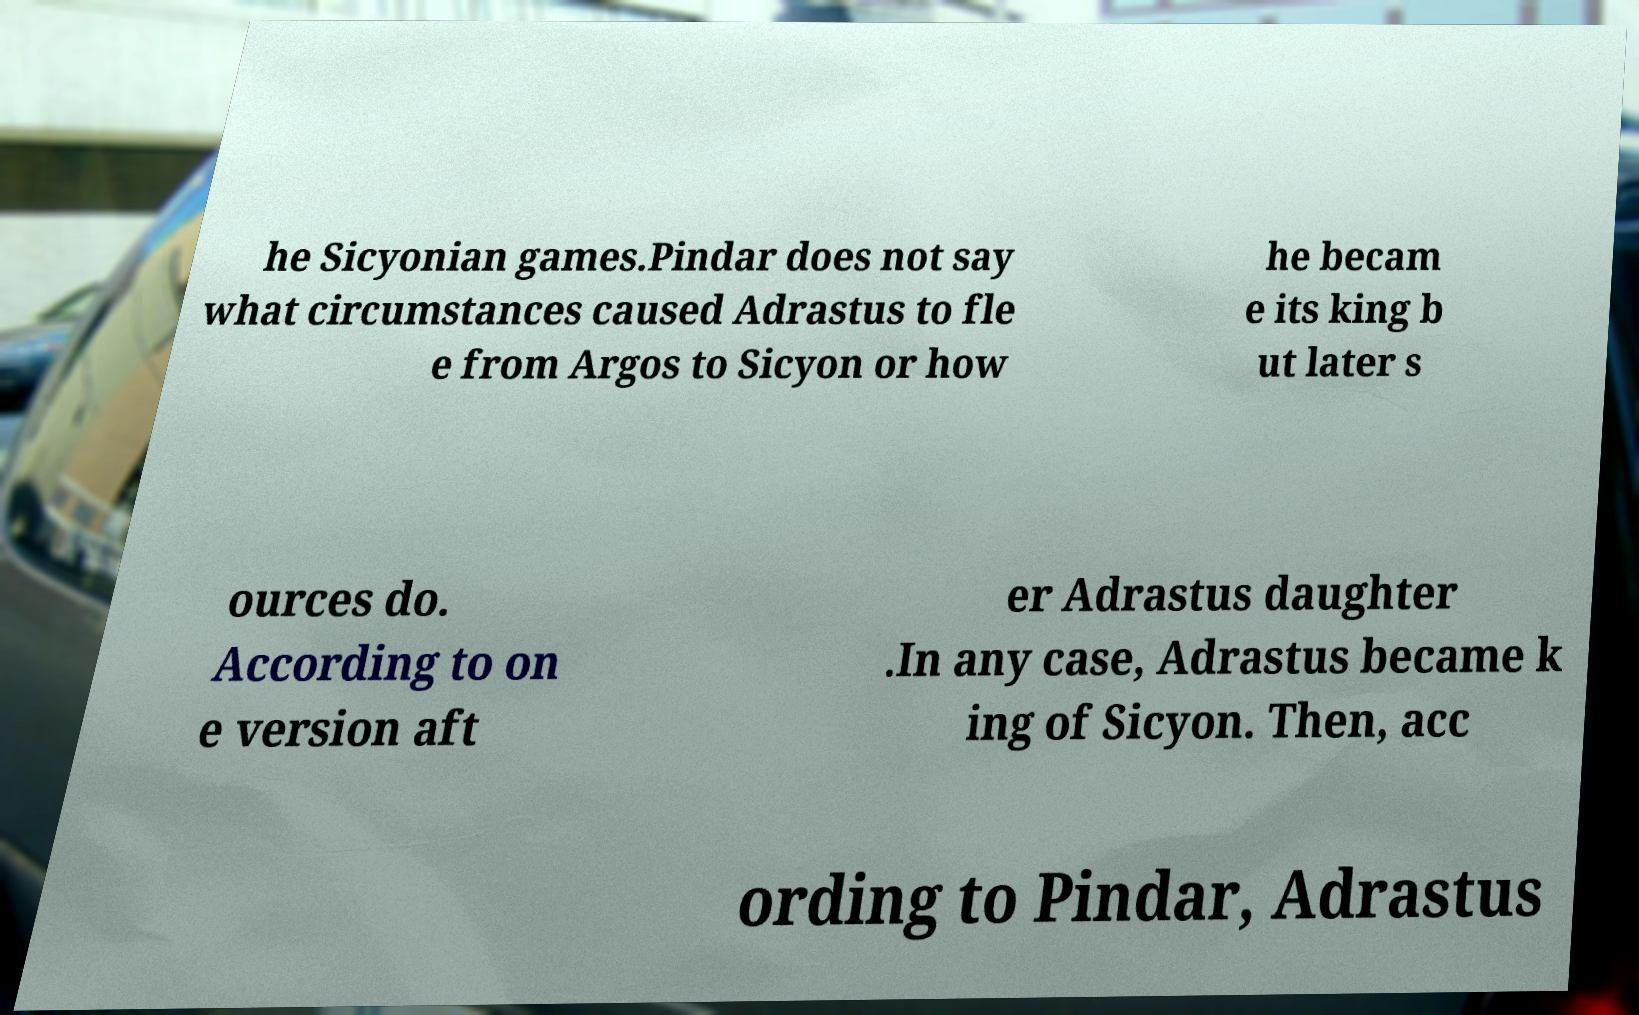For documentation purposes, I need the text within this image transcribed. Could you provide that? he Sicyonian games.Pindar does not say what circumstances caused Adrastus to fle e from Argos to Sicyon or how he becam e its king b ut later s ources do. According to on e version aft er Adrastus daughter .In any case, Adrastus became k ing of Sicyon. Then, acc ording to Pindar, Adrastus 